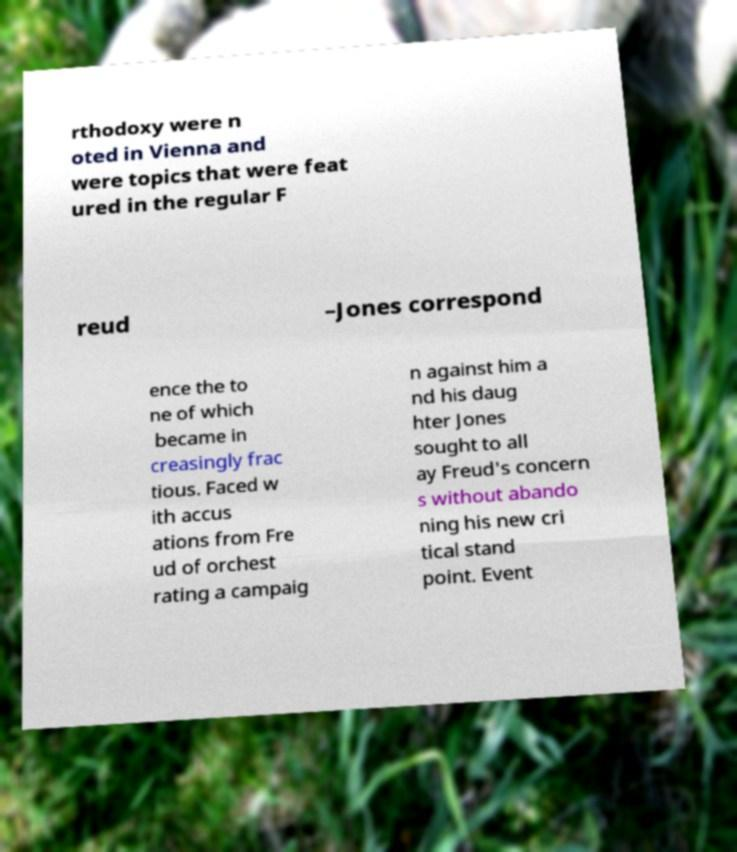I need the written content from this picture converted into text. Can you do that? rthodoxy were n oted in Vienna and were topics that were feat ured in the regular F reud –Jones correspond ence the to ne of which became in creasingly frac tious. Faced w ith accus ations from Fre ud of orchest rating a campaig n against him a nd his daug hter Jones sought to all ay Freud's concern s without abando ning his new cri tical stand point. Event 